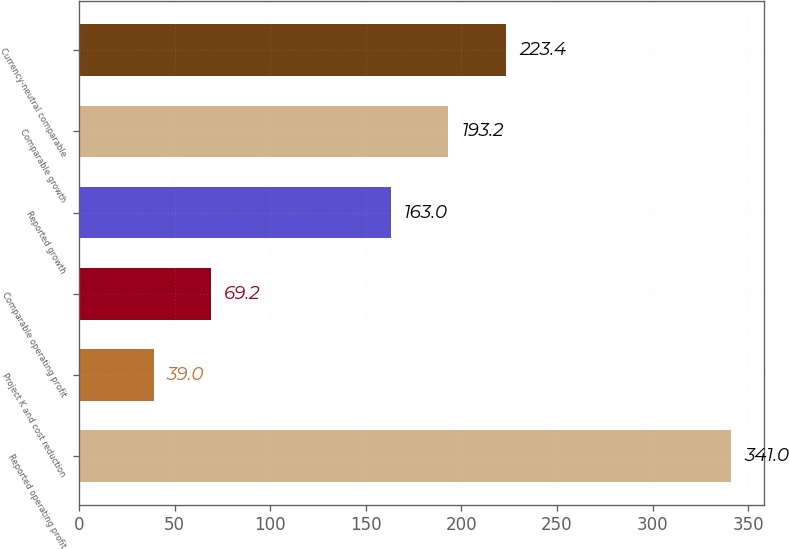<chart> <loc_0><loc_0><loc_500><loc_500><bar_chart><fcel>Reported operating profit<fcel>Project K and cost reduction<fcel>Comparable operating profit<fcel>Reported growth<fcel>Comparable growth<fcel>Currency-neutral comparable<nl><fcel>341<fcel>39<fcel>69.2<fcel>163<fcel>193.2<fcel>223.4<nl></chart> 